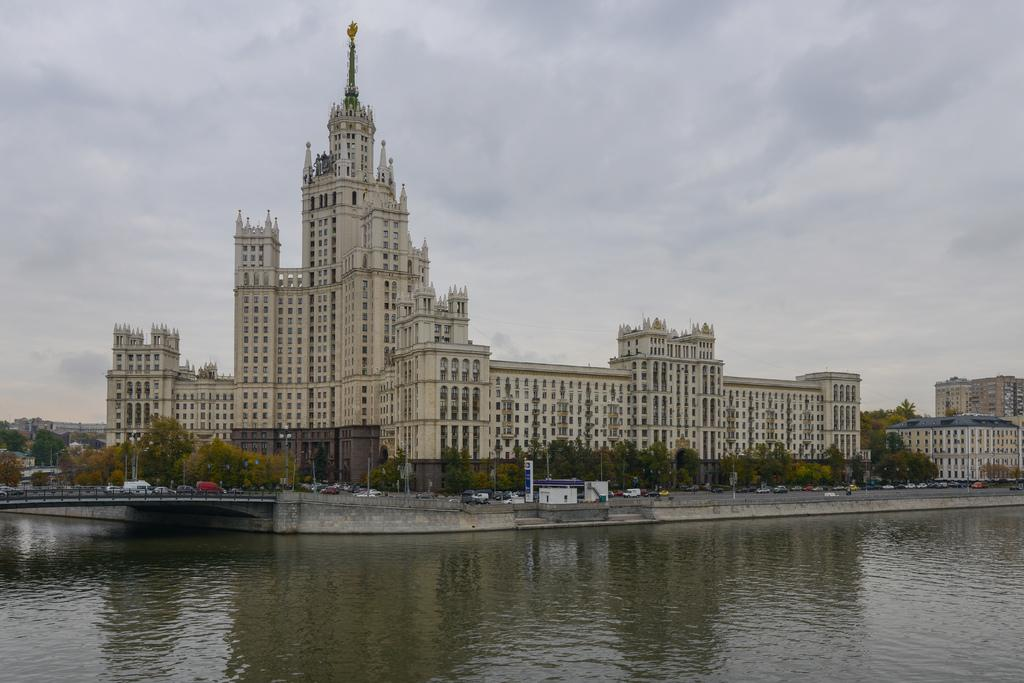What type of natural feature can be seen at the bottom of the image? There is a river at the bottom of the image. What structures are located in the center of the image? Buildings, trees, poles, cars, a wall, and a walkway are present in the center of the image. What is visible at the top of the image? The sky is visible at the top of the image. Can you tell me how many grapes are hanging from the trees in the image? There are no grapes present in the image; the trees are not specified as fruit-bearing trees. What type of flight is taking place in the image? There is no flight or any indication of an aircraft in the image. 